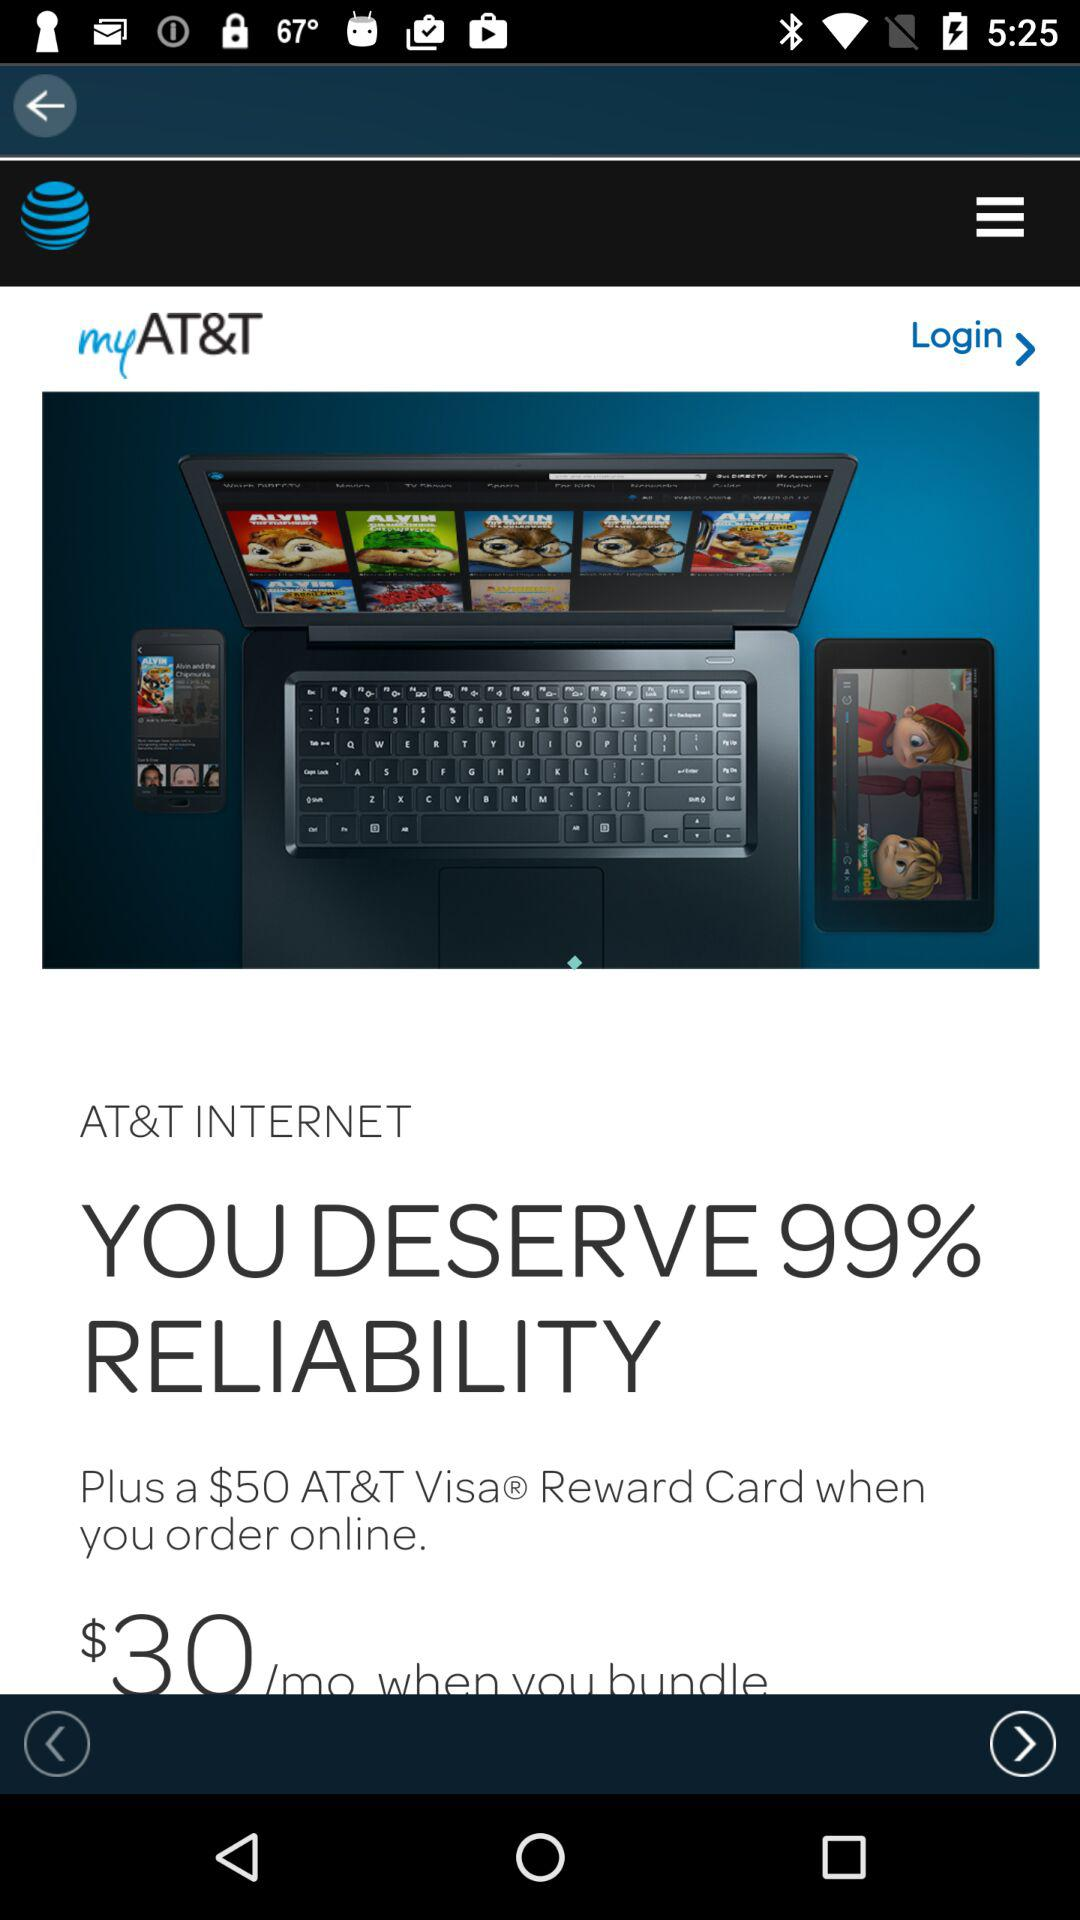What rewards do we get for ordering online? You get a $50 "AT&T" Visa Reward Card for ordering online. 